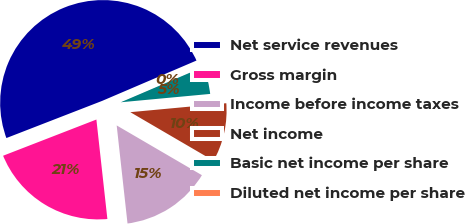Convert chart. <chart><loc_0><loc_0><loc_500><loc_500><pie_chart><fcel>Net service revenues<fcel>Gross margin<fcel>Income before income taxes<fcel>Net income<fcel>Basic net income per share<fcel>Diluted net income per share<nl><fcel>49.46%<fcel>20.86%<fcel>14.84%<fcel>9.89%<fcel>4.95%<fcel>0.0%<nl></chart> 